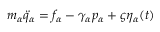Convert formula to latex. <formula><loc_0><loc_0><loc_500><loc_500>\begin{array} { r } { m _ { \alpha } \ddot { q } _ { \alpha } = f _ { \alpha } - \gamma _ { \alpha } p _ { \alpha } + \varsigma \eta _ { \alpha } ( t ) } \end{array}</formula> 